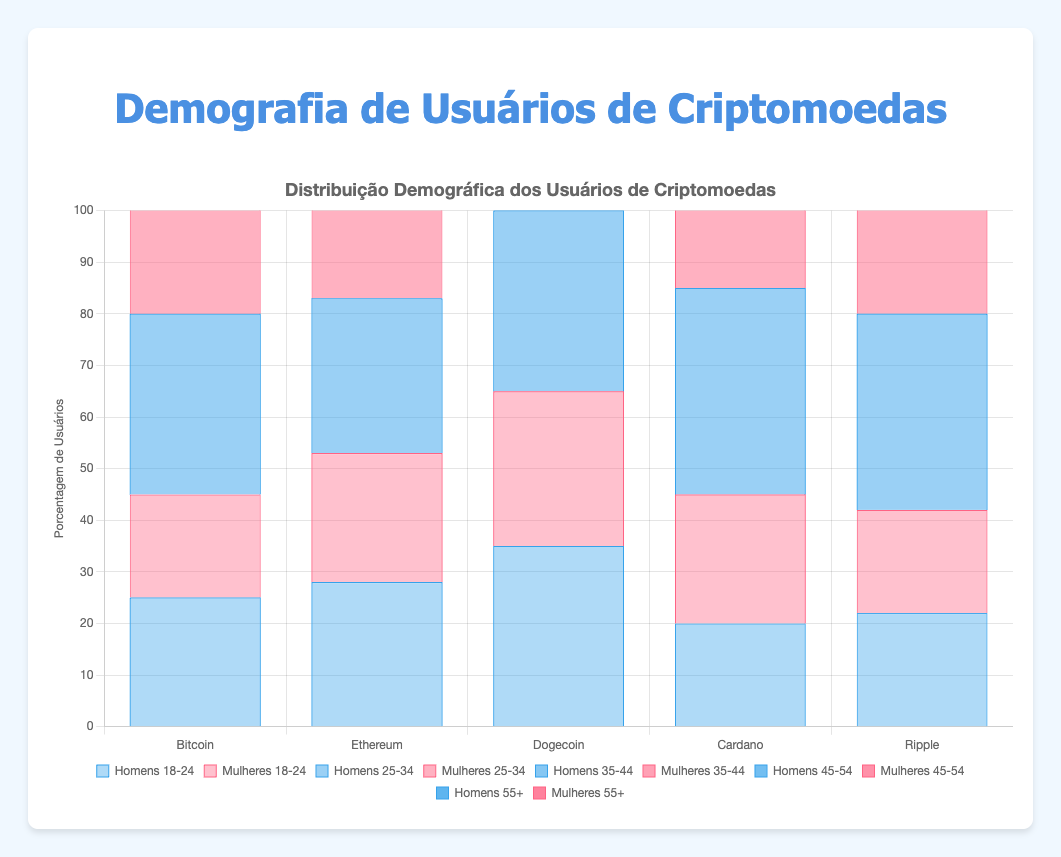What's the age group with the highest male representation in Bitcoin users? To answer this, look at the bar heights for the Bitcoin category under the male demographic. The highest bar corresponds to the 25-34 age group at 35%.
Answer: 25-34 Compare the female percentage of Dogecoin users aged 25-34 to the male percentage in the same age group. Which is higher? For Dogecoin, the figure for females aged 25-34 is 40%, while for males, it is 35%.
Answer: Female What is the combined percentage of males aged 18-34 using Cardano? Add the percentages of males using Cardano in the 18-24 and 25-34 age groups: 20% + 40% = 60%.
Answer: 60% Among Ripple users, what is the percentage difference between females aged 25-34 and females aged 35-44? For Ripple, females aged 25-34 are 40% and those aged 35-44 are 25%. The difference is 40% - 25% = 15%.
Answer: 15% Which cryptocurrency has the lowest percentage of male users aged 55+? Compare the bars for male users aged 55+ across all cryptocurrencies. Ethereum and Ripple both have a low of 5%.
Answer: Ethereum and Ripple Across all cryptocurrencies, what is the total percentage of female users aged 35-44? Sum the percentages of female users aged 35-44 for all cryptocurrencies: 25% (Bitcoin) + 25% (Ethereum) + 20% (Dogecoin) + 25% (Cardano) + 25% (Ripple) = 120%.
Answer: 120% What is the most visually prominent color used for female age groups on the chart? The shades of red are used for female age groups. The height and placement indicate a prominent visual characteristic.
Answer: Red For Ethereum, what is the combined percentage of users aged 45+ (both genders)? Combine the percentages of male and female users aged 45-54 and 55+: (10% + 7% for males) + (10% + 5% for females) = 32%.
Answer: 32% Which age group has a higher percentage of users for Dogecoin, males aged 18-24 or females aged 25-34? For Dogecoin, males aged 18-24 are at 35% and females aged 25-34 are at 40%. Females aged 25-34 is higher.
Answer: Females aged 25-34 How does the percentage of female users aged 18-24 compare between Bitcoin and Cardano? For Bitcoin, the female users aged 18-24 are 20%, while for Cardano, they are 25%. Cardano has a higher percentage.
Answer: Cardano 